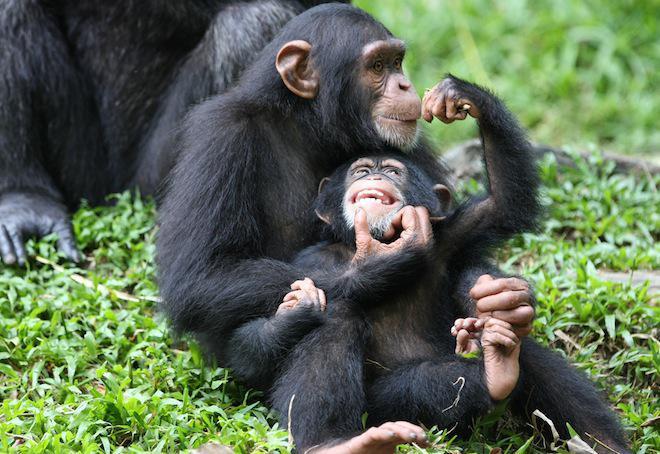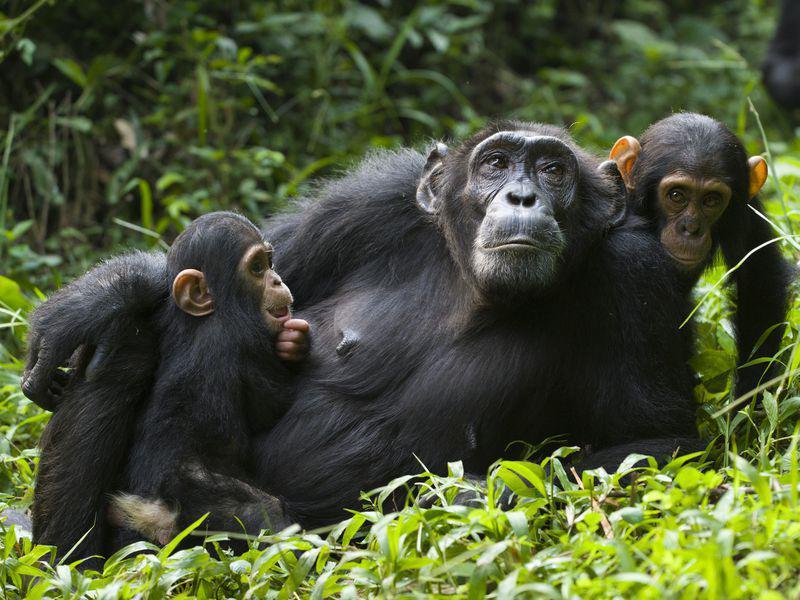The first image is the image on the left, the second image is the image on the right. For the images displayed, is the sentence "None of the chimpanzees appear to be young babies or toddlers; all are fully grown." factually correct? Answer yes or no. No. The first image is the image on the left, the second image is the image on the right. For the images shown, is this caption "There is atleast one extremely small baby monkey sitting next to a bigger adult sized monkey." true? Answer yes or no. Yes. 